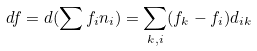<formula> <loc_0><loc_0><loc_500><loc_500>d f = d ( \sum f _ { i } n _ { i } ) = \sum _ { k , i } ( f _ { k } - f _ { i } ) d _ { i k }</formula> 